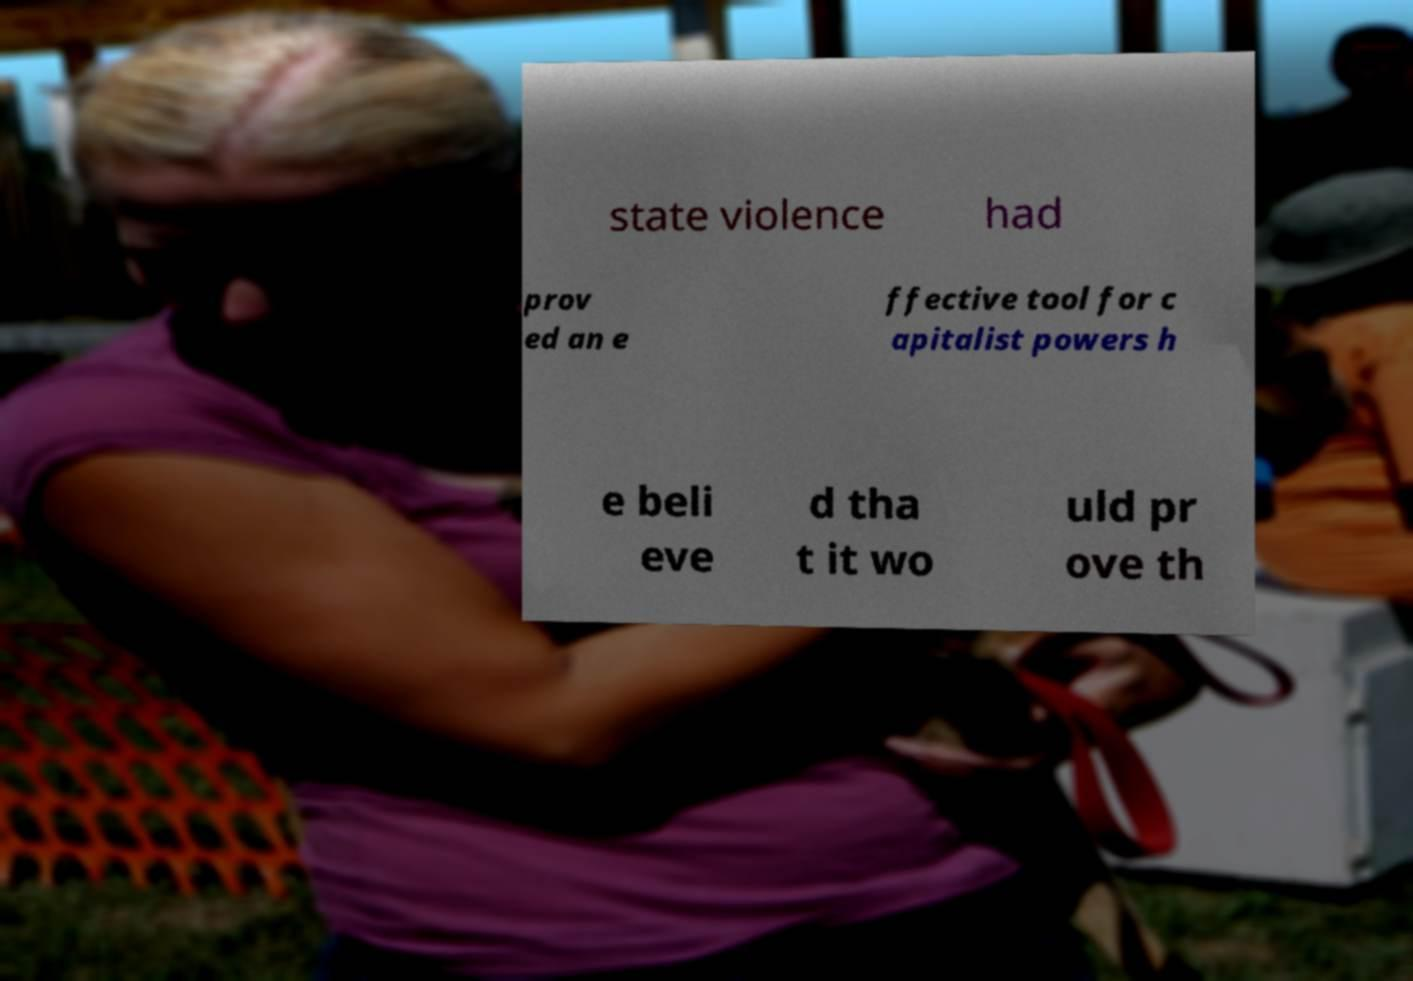Please identify and transcribe the text found in this image. state violence had prov ed an e ffective tool for c apitalist powers h e beli eve d tha t it wo uld pr ove th 